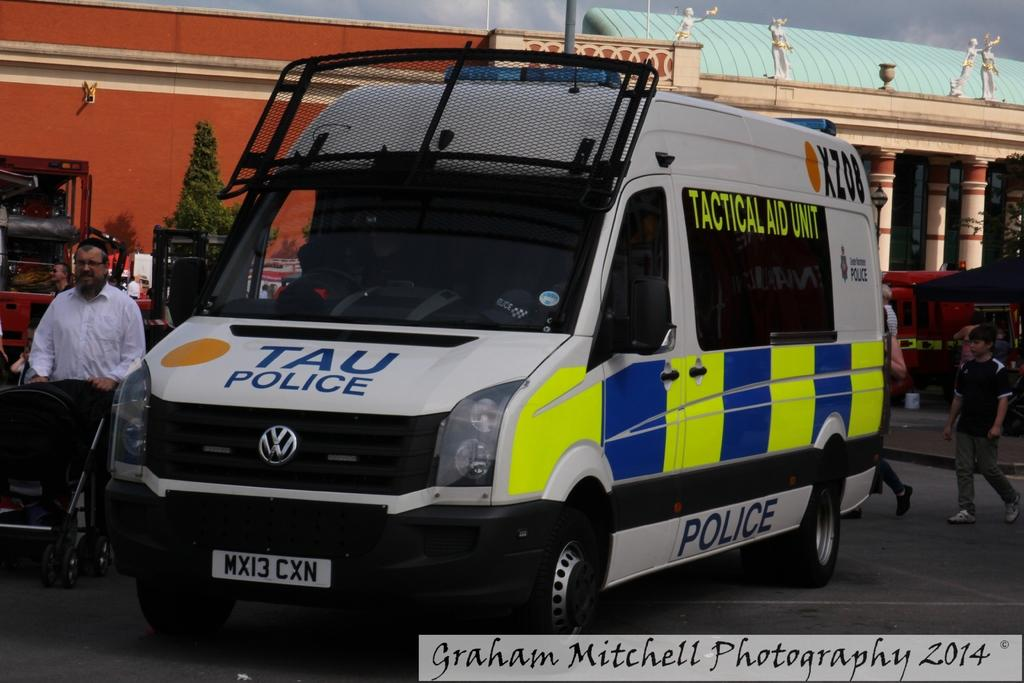<image>
Create a compact narrative representing the image presented. TAU police van that is parked on the road with people walking by it 